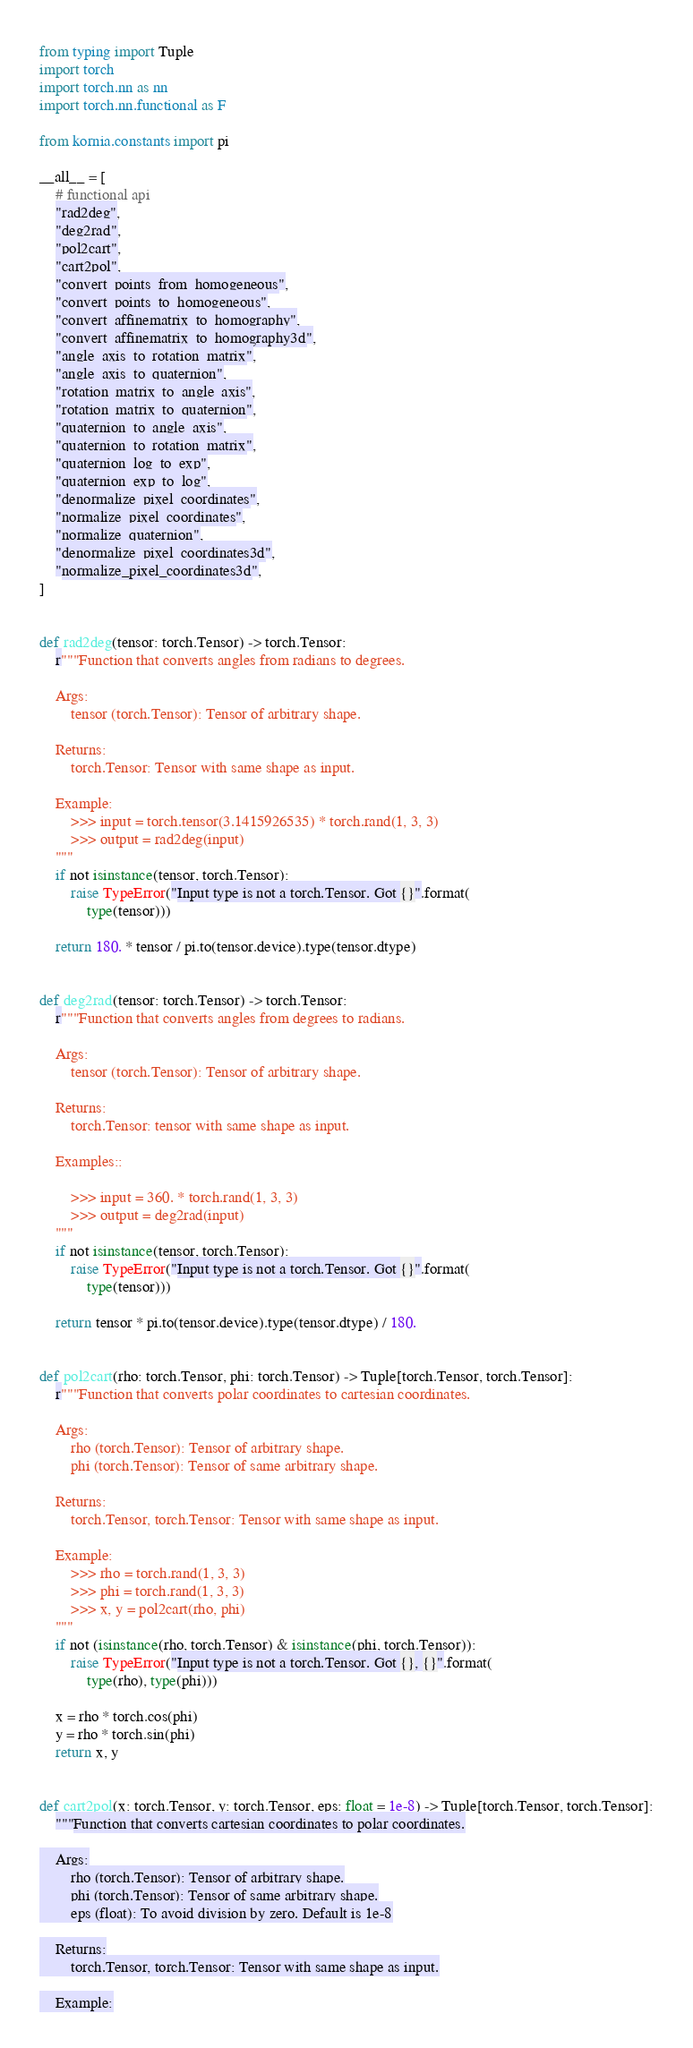Convert code to text. <code><loc_0><loc_0><loc_500><loc_500><_Python_>from typing import Tuple
import torch
import torch.nn as nn
import torch.nn.functional as F

from kornia.constants import pi

__all__ = [
    # functional api
    "rad2deg",
    "deg2rad",
    "pol2cart",
    "cart2pol",
    "convert_points_from_homogeneous",
    "convert_points_to_homogeneous",
    "convert_affinematrix_to_homography",
    "convert_affinematrix_to_homography3d",
    "angle_axis_to_rotation_matrix",
    "angle_axis_to_quaternion",
    "rotation_matrix_to_angle_axis",
    "rotation_matrix_to_quaternion",
    "quaternion_to_angle_axis",
    "quaternion_to_rotation_matrix",
    "quaternion_log_to_exp",
    "quaternion_exp_to_log",
    "denormalize_pixel_coordinates",
    "normalize_pixel_coordinates",
    "normalize_quaternion",
    "denormalize_pixel_coordinates3d",
    "normalize_pixel_coordinates3d",
]


def rad2deg(tensor: torch.Tensor) -> torch.Tensor:
    r"""Function that converts angles from radians to degrees.

    Args:
        tensor (torch.Tensor): Tensor of arbitrary shape.

    Returns:
        torch.Tensor: Tensor with same shape as input.

    Example:
        >>> input = torch.tensor(3.1415926535) * torch.rand(1, 3, 3)
        >>> output = rad2deg(input)
    """
    if not isinstance(tensor, torch.Tensor):
        raise TypeError("Input type is not a torch.Tensor. Got {}".format(
            type(tensor)))

    return 180. * tensor / pi.to(tensor.device).type(tensor.dtype)


def deg2rad(tensor: torch.Tensor) -> torch.Tensor:
    r"""Function that converts angles from degrees to radians.

    Args:
        tensor (torch.Tensor): Tensor of arbitrary shape.

    Returns:
        torch.Tensor: tensor with same shape as input.

    Examples::

        >>> input = 360. * torch.rand(1, 3, 3)
        >>> output = deg2rad(input)
    """
    if not isinstance(tensor, torch.Tensor):
        raise TypeError("Input type is not a torch.Tensor. Got {}".format(
            type(tensor)))

    return tensor * pi.to(tensor.device).type(tensor.dtype) / 180.


def pol2cart(rho: torch.Tensor, phi: torch.Tensor) -> Tuple[torch.Tensor, torch.Tensor]:
    r"""Function that converts polar coordinates to cartesian coordinates.

    Args:
        rho (torch.Tensor): Tensor of arbitrary shape.
        phi (torch.Tensor): Tensor of same arbitrary shape.

    Returns:
        torch.Tensor, torch.Tensor: Tensor with same shape as input.

    Example:
        >>> rho = torch.rand(1, 3, 3)
        >>> phi = torch.rand(1, 3, 3)
        >>> x, y = pol2cart(rho, phi)
    """
    if not (isinstance(rho, torch.Tensor) & isinstance(phi, torch.Tensor)):
        raise TypeError("Input type is not a torch.Tensor. Got {}, {}".format(
            type(rho), type(phi)))

    x = rho * torch.cos(phi)
    y = rho * torch.sin(phi)
    return x, y


def cart2pol(x: torch.Tensor, y: torch.Tensor, eps: float = 1e-8) -> Tuple[torch.Tensor, torch.Tensor]:
    """Function that converts cartesian coordinates to polar coordinates.

    Args:
        rho (torch.Tensor): Tensor of arbitrary shape.
        phi (torch.Tensor): Tensor of same arbitrary shape.
        eps (float): To avoid division by zero. Default is 1e-8

    Returns:
        torch.Tensor, torch.Tensor: Tensor with same shape as input.

    Example:</code> 